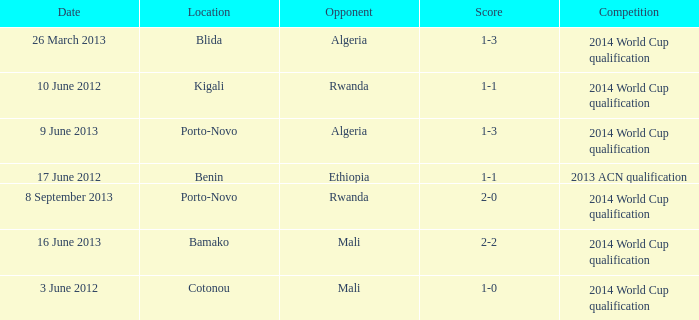What is the score from the game where Algeria is the opponent at Porto-Novo? 1-3. 